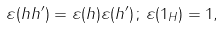<formula> <loc_0><loc_0><loc_500><loc_500>\varepsilon ( h h ^ { \prime } ) = \varepsilon ( h ) \varepsilon ( h ^ { \prime } ) \, ; \, \varepsilon ( 1 _ { H } ) = 1 ,</formula> 